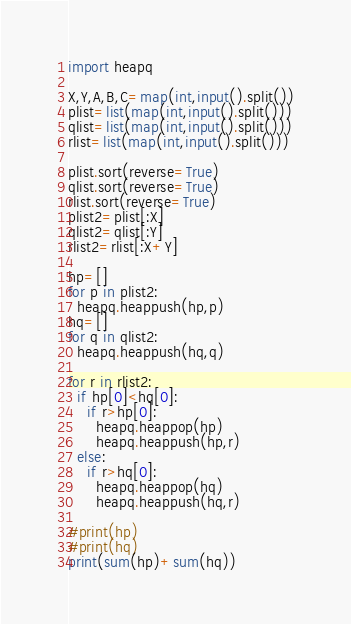Convert code to text. <code><loc_0><loc_0><loc_500><loc_500><_Python_>import heapq

X,Y,A,B,C=map(int,input().split())
plist=list(map(int,input().split()))
qlist=list(map(int,input().split()))
rlist=list(map(int,input().split()))

plist.sort(reverse=True)
qlist.sort(reverse=True)
rlist.sort(reverse=True)
plist2=plist[:X]
qlist2=qlist[:Y]
rlist2=rlist[:X+Y]

hp=[]
for p in plist2:
  heapq.heappush(hp,p)
hq=[]
for q in qlist2:
  heapq.heappush(hq,q)
  
for r in rlist2:
  if hp[0]<hq[0]:
    if r>hp[0]:
      heapq.heappop(hp)
      heapq.heappush(hp,r)
  else:
    if r>hq[0]:
      heapq.heappop(hq)
      heapq.heappush(hq,r)
      
#print(hp)
#print(hq)
print(sum(hp)+sum(hq))
</code> 